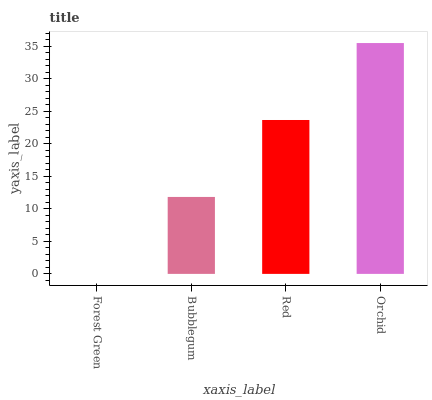Is Forest Green the minimum?
Answer yes or no. Yes. Is Orchid the maximum?
Answer yes or no. Yes. Is Bubblegum the minimum?
Answer yes or no. No. Is Bubblegum the maximum?
Answer yes or no. No. Is Bubblegum greater than Forest Green?
Answer yes or no. Yes. Is Forest Green less than Bubblegum?
Answer yes or no. Yes. Is Forest Green greater than Bubblegum?
Answer yes or no. No. Is Bubblegum less than Forest Green?
Answer yes or no. No. Is Red the high median?
Answer yes or no. Yes. Is Bubblegum the low median?
Answer yes or no. Yes. Is Orchid the high median?
Answer yes or no. No. Is Orchid the low median?
Answer yes or no. No. 